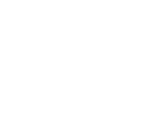Convert formula to latex. <formula><loc_0><loc_0><loc_500><loc_500>\begin{smallmatrix} 2 & 1 & 1 & 1 & 1 & 0 & 0 \\ 1 & 3 & 1 & 1 & 1 & 1 & 0 \\ 1 & 1 & 3 & 1 & 1 & 0 & 0 \\ 1 & 1 & 1 & 3 & 0 & 1 & 1 \\ 1 & 1 & 1 & 0 & 3 & 0 & 0 \\ 0 & 1 & 0 & 1 & 0 & 3 & 0 \\ 0 & 0 & 0 & 1 & 0 & 0 & 3 \end{smallmatrix}</formula> 